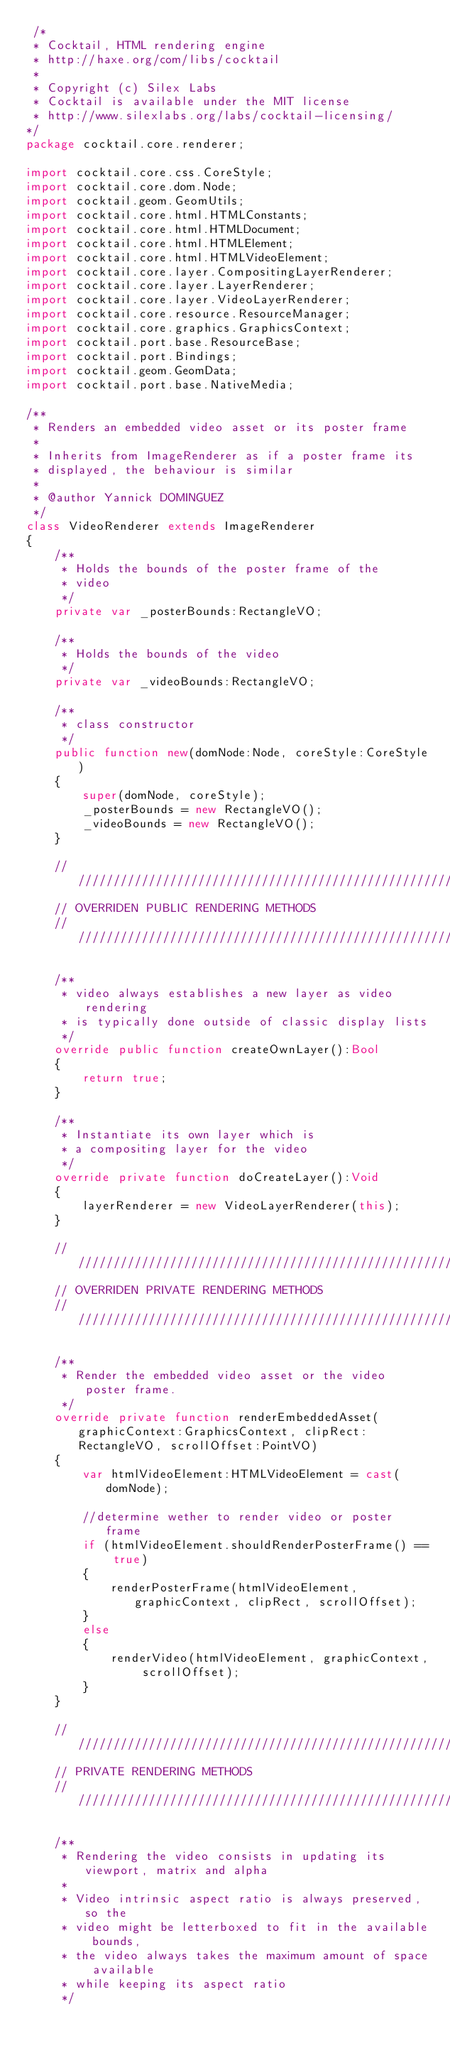Convert code to text. <code><loc_0><loc_0><loc_500><loc_500><_Haxe_> /*
 * Cocktail, HTML rendering engine
 * http://haxe.org/com/libs/cocktail
 *
 * Copyright (c) Silex Labs
 * Cocktail is available under the MIT license
 * http://www.silexlabs.org/labs/cocktail-licensing/
*/
package cocktail.core.renderer;

import cocktail.core.css.CoreStyle;
import cocktail.core.dom.Node;
import cocktail.geom.GeomUtils;
import cocktail.core.html.HTMLConstants;
import cocktail.core.html.HTMLDocument;
import cocktail.core.html.HTMLElement;
import cocktail.core.html.HTMLVideoElement;
import cocktail.core.layer.CompositingLayerRenderer;
import cocktail.core.layer.LayerRenderer;
import cocktail.core.layer.VideoLayerRenderer;
import cocktail.core.resource.ResourceManager;
import cocktail.core.graphics.GraphicsContext;
import cocktail.port.base.ResourceBase;
import cocktail.port.Bindings;
import cocktail.geom.GeomData;
import cocktail.port.base.NativeMedia;

/**
 * Renders an embedded video asset or its poster frame
 * 
 * Inherits from ImageRenderer as if a poster frame its
 * displayed, the behaviour is similar
 * 
 * @author Yannick DOMINGUEZ
 */
class VideoRenderer extends ImageRenderer
{
	/**
	 * Holds the bounds of the poster frame of the
	 * video
	 */
	private var _posterBounds:RectangleVO;
	
	/**
	 * Holds the bounds of the video
	 */
	private var _videoBounds:RectangleVO;
	
	/**
	 * class constructor
	 */
	public function new(domNode:Node, coreStyle:CoreStyle) 
	{
		super(domNode, coreStyle);
		_posterBounds = new RectangleVO();
		_videoBounds = new RectangleVO();
	}
	
	//////////////////////////////////////////////////////////////////////////////////////////
	// OVERRIDEN PUBLIC RENDERING METHODS
	//////////////////////////////////////////////////////////////////////////////////////////
	
	/**
	 * video always establishes a new layer as video rendering
	 * is typically done outside of classic display lists
	 */
	override public function createOwnLayer():Bool
	{
		return true;
	}
	
	/**
	 * Instantiate its own layer which is
	 * a compositing layer for the video
	 */
	override private function doCreateLayer():Void
	{
		layerRenderer = new VideoLayerRenderer(this);
	}
	
	//////////////////////////////////////////////////////////////////////////////////////////
	// OVERRIDEN PRIVATE RENDERING METHODS
	//////////////////////////////////////////////////////////////////////////////////////////
	
	/**
	 * Render the embedded video asset or the video poster frame.
	 */
	override private function renderEmbeddedAsset(graphicContext:GraphicsContext, clipRect:RectangleVO, scrollOffset:PointVO)
	{
		var htmlVideoElement:HTMLVideoElement = cast(domNode);
		
		//determine wether to render video or poster frame
		if (htmlVideoElement.shouldRenderPosterFrame() == true)
		{
			renderPosterFrame(htmlVideoElement, graphicContext, clipRect, scrollOffset);
		}
		else
		{
			renderVideo(htmlVideoElement, graphicContext, scrollOffset);
		}
	}
	
	//////////////////////////////////////////////////////////////////////////////////////////
	// PRIVATE RENDERING METHODS
	//////////////////////////////////////////////////////////////////////////////////////////
	
	/**
	 * Rendering the video consists in updating its viewport, matrix and alpha
	 * 
	 * Video intrinsic aspect ratio is always preserved, so the
	 * video might be letterboxed to fit in the available bounds,
	 * the video always takes the maximum amount of space available
	 * while keeping its aspect ratio
	 */</code> 